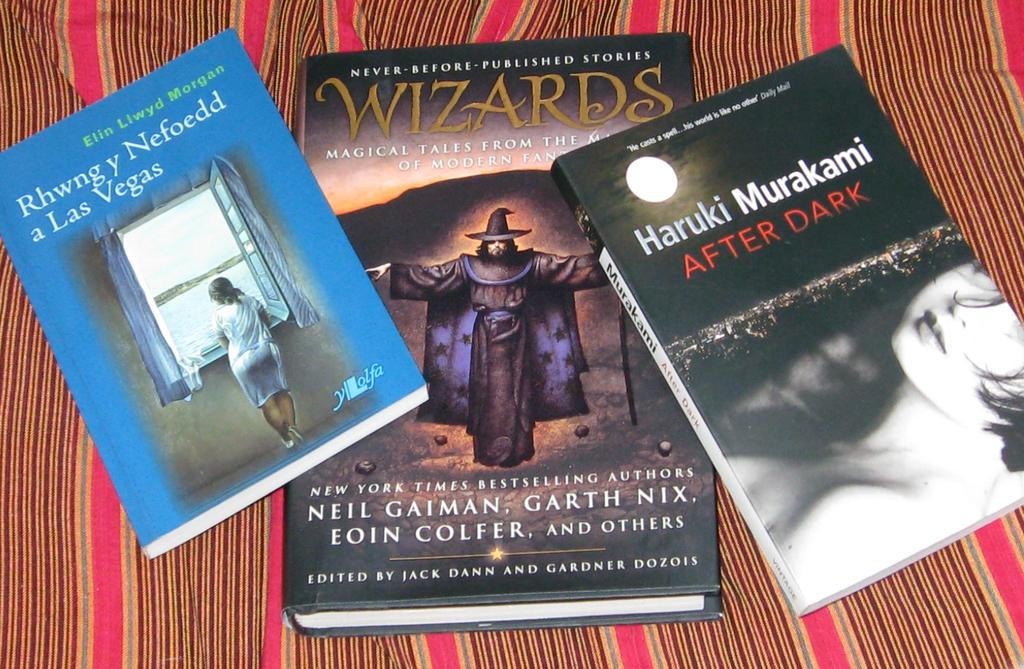<image>
Summarize the visual content of the image. One of the three books is about Wizards and the others are about Las Vegas and Haruki Murakami After Dark. 